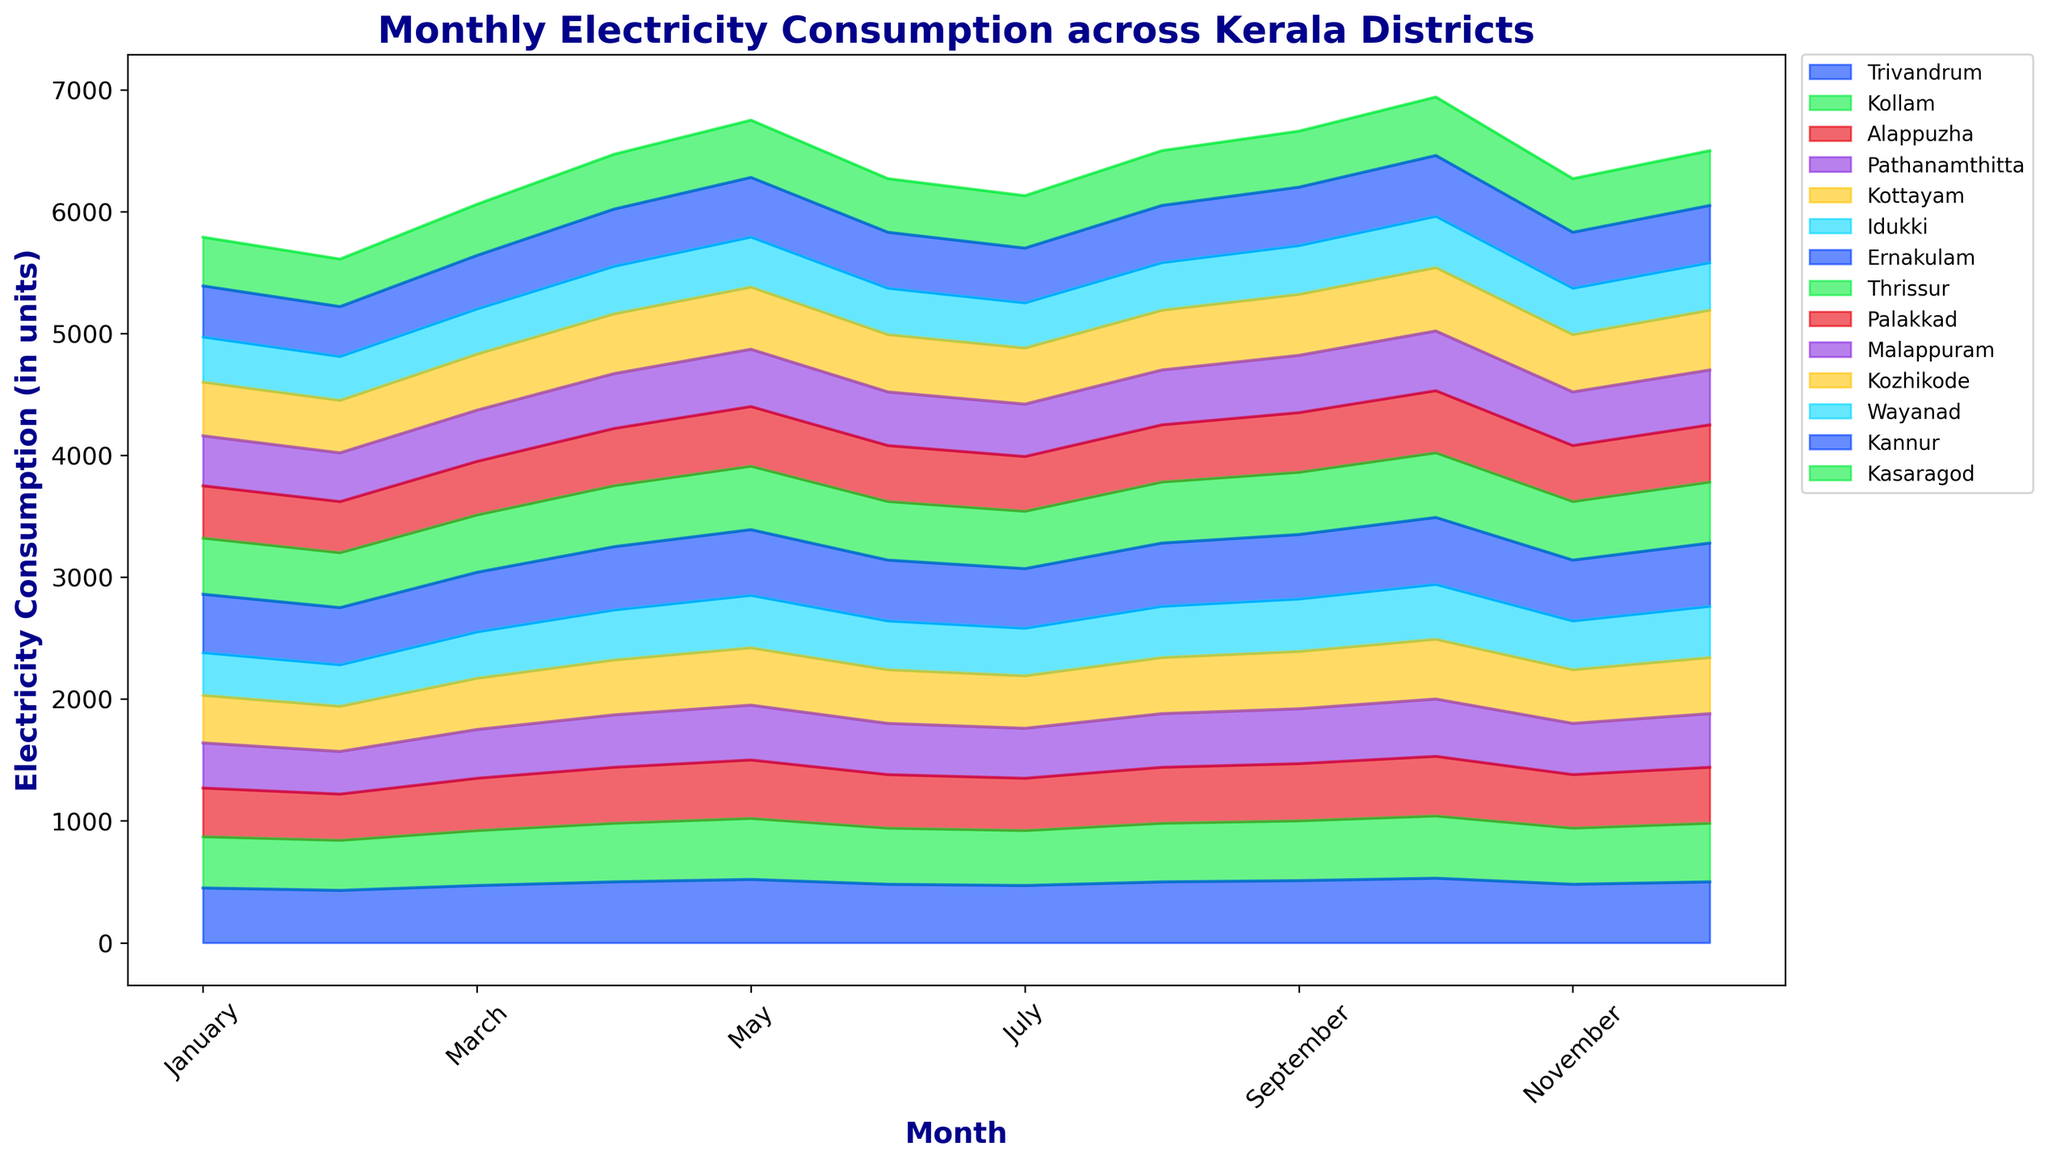Which district had the highest electricity consumption in October? By looking at the plot for October, we see the stacked area sections. The topmost point of the stack in October corresponds to 'Ernakulam'.
Answer: Ernakulam Compare the electricity consumption patterns of Trivandrum and Kozhikode. Which district had higher consumption in July? Look at the plot for July, and compare the heights of the sections labeled 'Trivandrum' and 'Kozhikode'. 'Trivandrum' has a higher section height in July.
Answer: Trivandrum What is the total electricity consumption in Kerala in April? Sum the electricity consumption values across all districts for April: 500 + 480 + 460 + 430 + 450 + 410 + 520 + 500 + 470 + 450 + 490 + 390 + 470 + 450.
Answer: 7430 Which months show a peak in electricity consumption across most districts? Identify the months where the area peaks. Notably, March, April, August, and October show prominent peaks across the majority of the districts.
Answer: March, April, August, October What is the difference in electricity consumption between January and February for Alappuzha? Subtract the February value from the January value for Alappuzha: 400 (January) - 380 (February).
Answer: 20 In which month did Malappuram have the lowest electricity consumption? Locate the month where the section height for 'Malappuram' is the shortest. February has the lowest value for Malappuram.
Answer: February Which district shows a steady increase in electricity consumption from January to December? Observe the trend lines for each district. 'Ernakulam' shows a consistent increase from January to December.
Answer: Ernakulam Is there any district that shows the same consumption for May and November? Identify it if any. Compare the consumption for May and November for each district. 'Wayanad' shows the same consumption in both months (410 units).
Answer: Wayanad During which month is the cumulative electricity consumption the highest? Sum the consumption values for each month across all districts and identify the highest cumulative sum. October has the highest cumulative electricity consumption.
Answer: October 